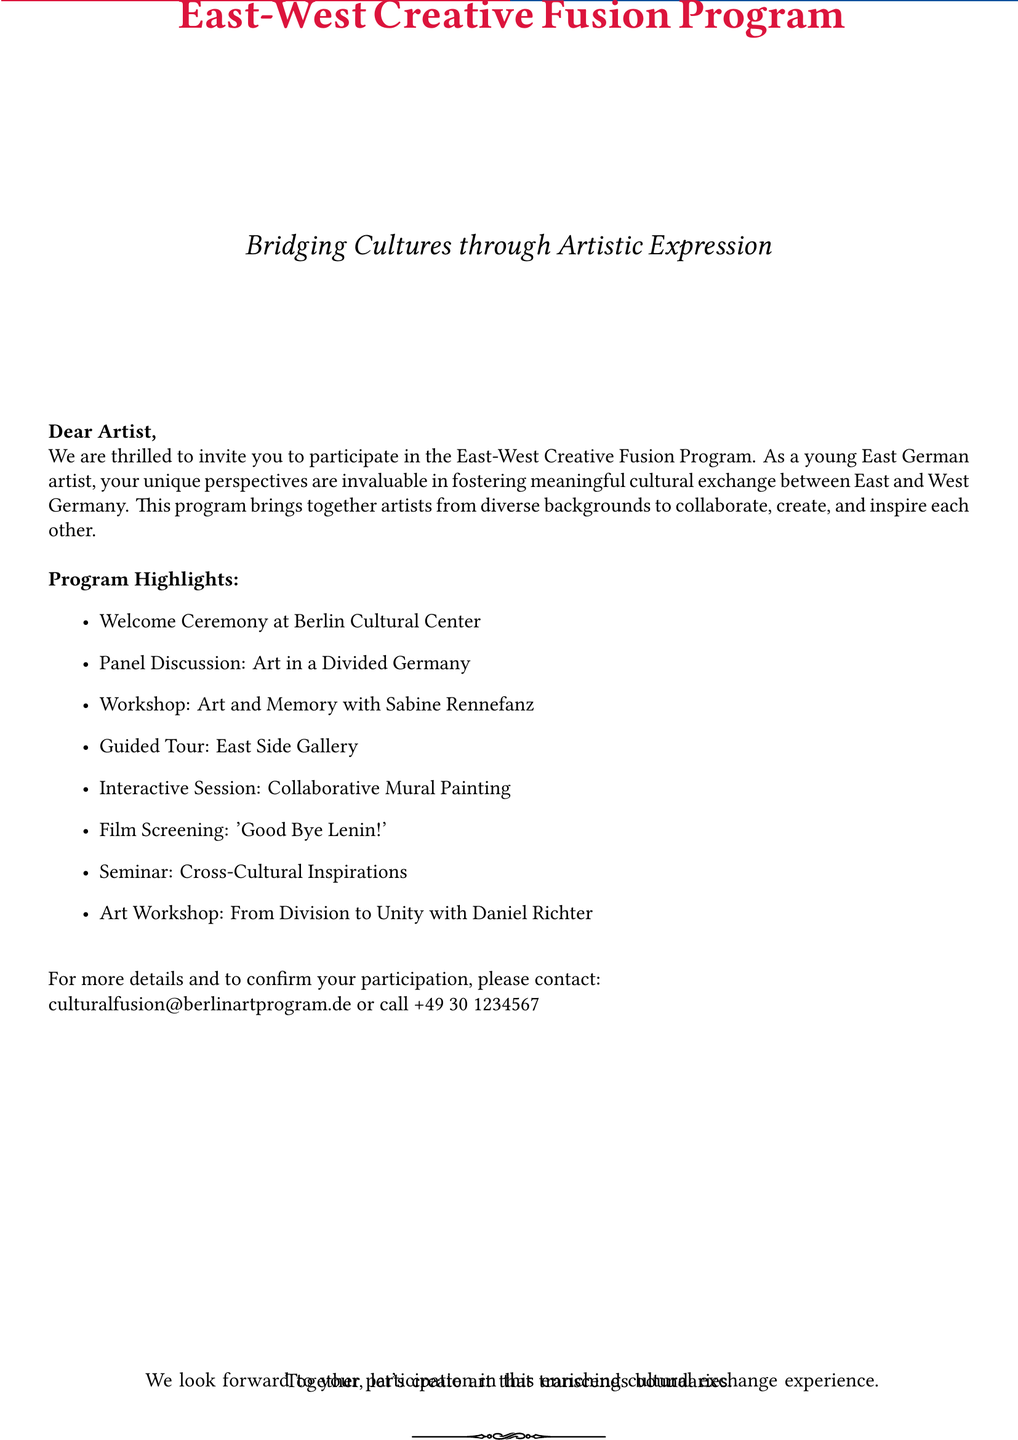What is the name of the program? The program is titled "East-West Creative Fusion Program" as mentioned prominently in the document.
Answer: East-West Creative Fusion Program Who is the target audience for this invitation? The invitation specifically addresses "young East German artists," indicating the target audience.
Answer: Young East German artists What is one of the workshop topics mentioned? The document lists several workshop topics, including "Art and Memory with Sabine Rennefanz."
Answer: Art and Memory What is the location of the welcome ceremony? The location for the welcome ceremony is identified as the "Berlin Cultural Center" in the document.
Answer: Berlin Cultural Center Which film is scheduled to be screened? The film mentioned for screening is "'Good Bye Lenin!'" noted in the program highlights.
Answer: Good Bye Lenin! What type of session includes collaborative work? The program highlights an "Interactive Session: Collaborative Mural Painting," focusing on collaboration.
Answer: Collaborative Mural Painting How can participants confirm their participation? The document provides two methods for confirmation: an email and a phone number.
Answer: Email and phone What is the aim of the program? The stated aim of the program is to foster "meaningful cultural exchange between East and West Germany."
Answer: Meaningful cultural exchange 